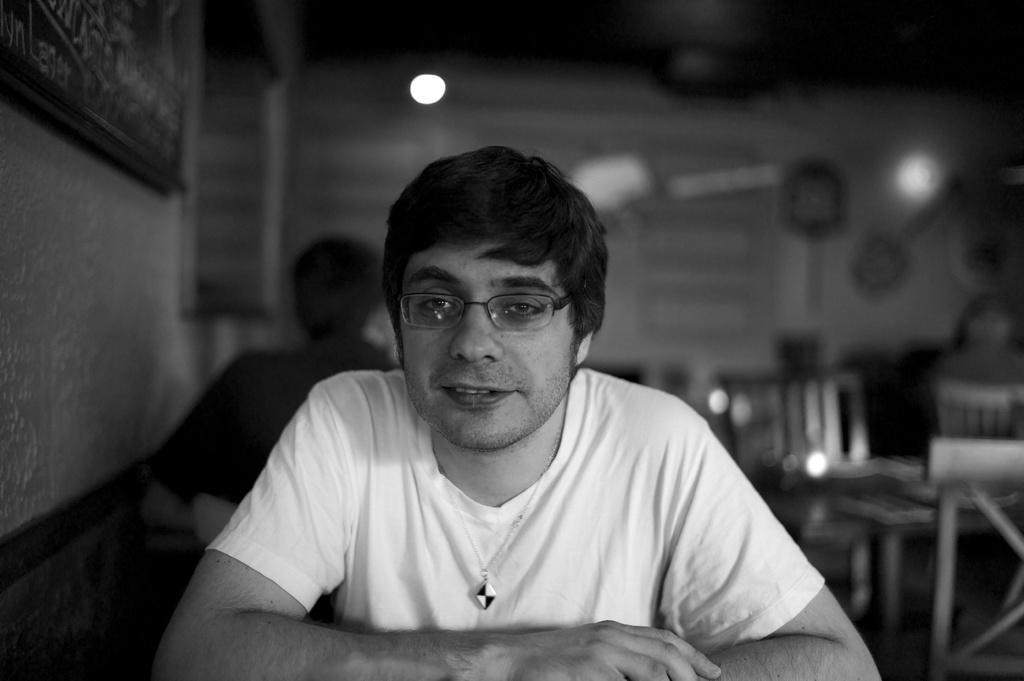Please provide a concise description of this image. The image looks like an edited picture. In the foreground we can see a person wearing white t-shirt and spectacles. On the left we can see wall and frame. The background is blurred yet we can see chairs, tables, person and light. 